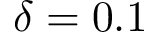<formula> <loc_0><loc_0><loc_500><loc_500>\delta = 0 . 1</formula> 